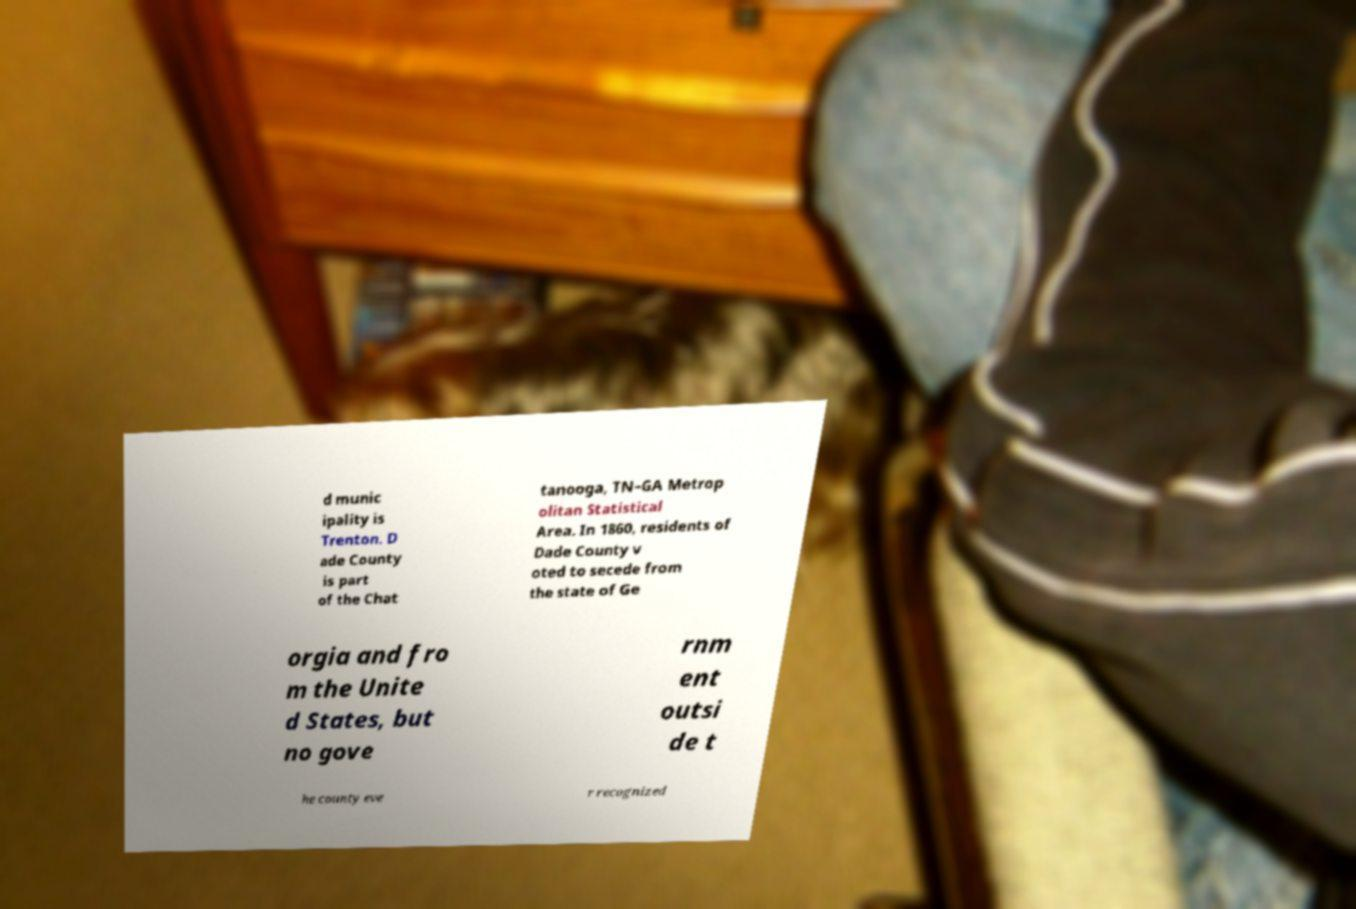There's text embedded in this image that I need extracted. Can you transcribe it verbatim? d munic ipality is Trenton. D ade County is part of the Chat tanooga, TN–GA Metrop olitan Statistical Area. In 1860, residents of Dade County v oted to secede from the state of Ge orgia and fro m the Unite d States, but no gove rnm ent outsi de t he county eve r recognized 